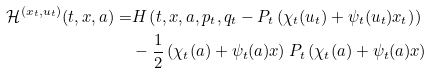<formula> <loc_0><loc_0><loc_500><loc_500>\mathcal { H } ^ { ( x _ { t } , u _ { t } ) } ( t , x , a ) = & H \left ( t , x , a , p _ { t } , q _ { t } - P _ { t } \left ( \chi _ { t } ( u _ { t } ) + \psi _ { t } ( u _ { t } ) x _ { t } \right ) \right ) \\ & - \frac { 1 } { 2 } \left ( \chi _ { t } ( a ) + \psi _ { t } ( a ) x \right ) P _ { t } \left ( \chi _ { t } ( a ) + \psi _ { t } ( a ) x \right )</formula> 